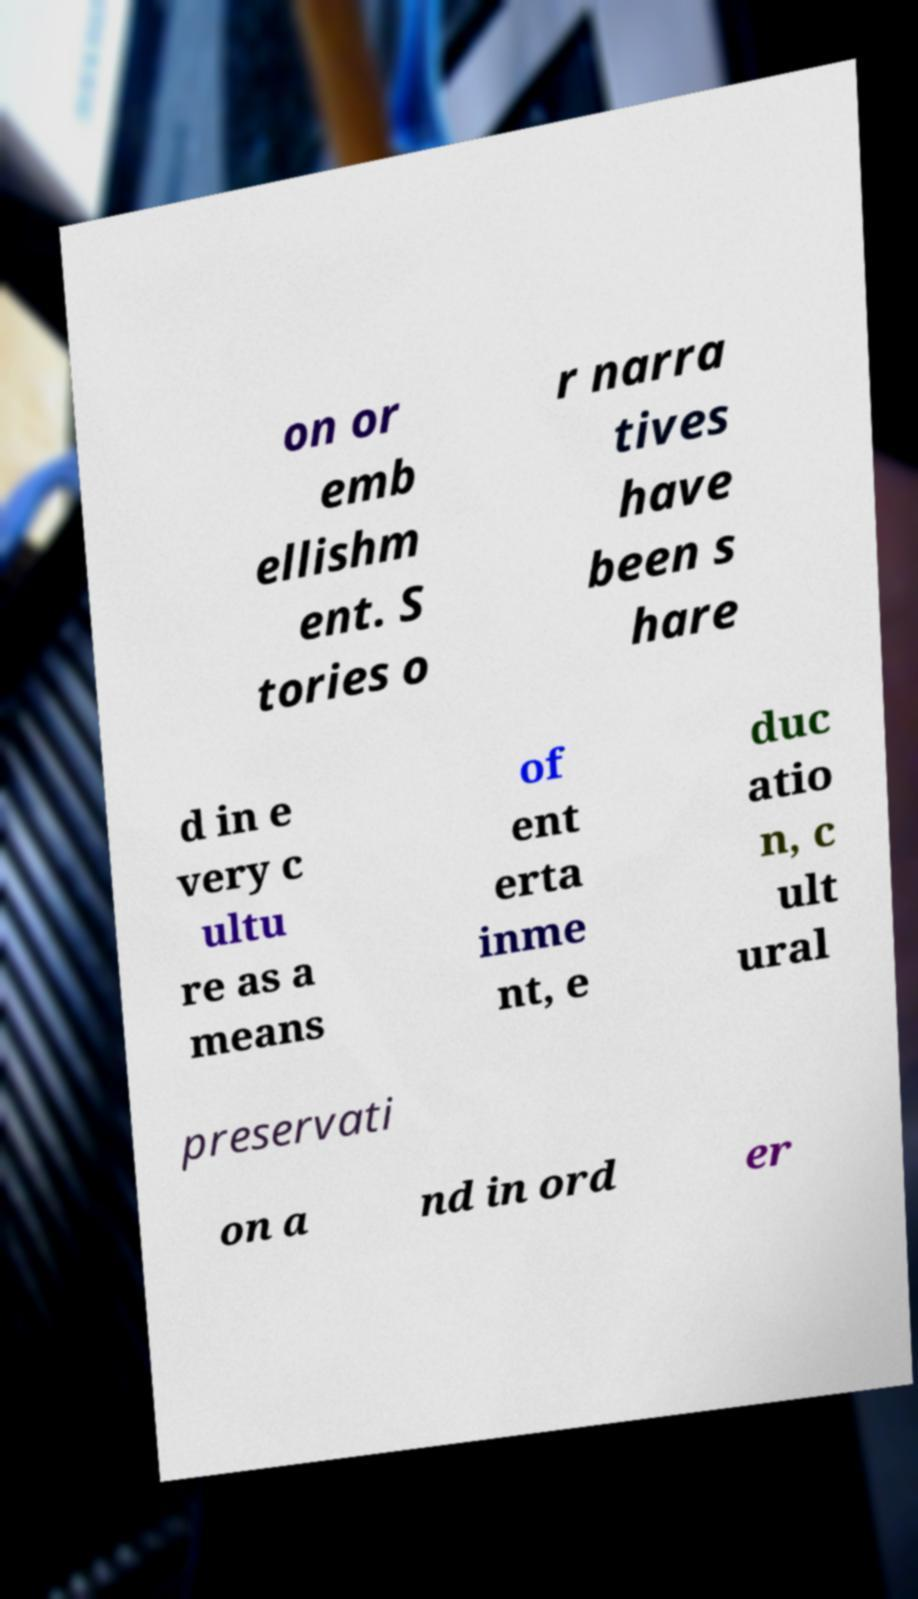Can you read and provide the text displayed in the image?This photo seems to have some interesting text. Can you extract and type it out for me? on or emb ellishm ent. S tories o r narra tives have been s hare d in e very c ultu re as a means of ent erta inme nt, e duc atio n, c ult ural preservati on a nd in ord er 